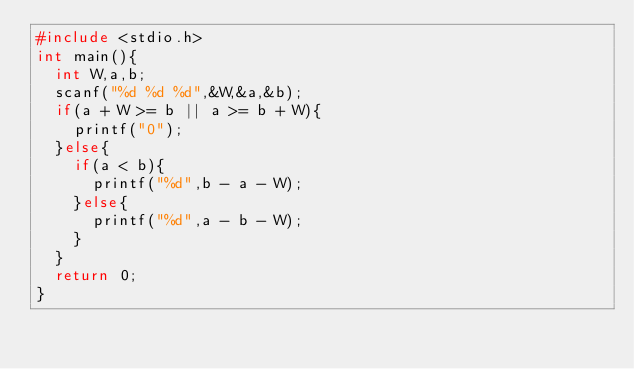Convert code to text. <code><loc_0><loc_0><loc_500><loc_500><_C_>#include <stdio.h>
int main(){
  int W,a,b;
  scanf("%d %d %d",&W,&a,&b);
  if(a + W >= b || a >= b + W){
    printf("0");
  }else{
    if(a < b){
      printf("%d",b - a - W);
    }else{
      printf("%d",a - b - W);
    }
  }
  return 0;
}</code> 